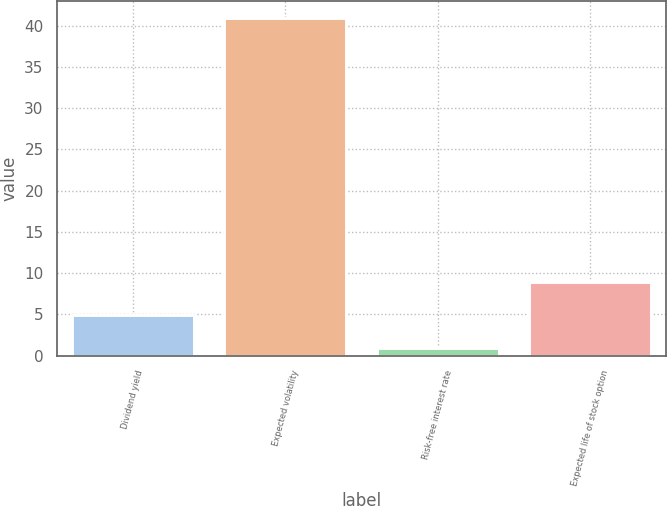Convert chart to OTSL. <chart><loc_0><loc_0><loc_500><loc_500><bar_chart><fcel>Dividend yield<fcel>Expected volatility<fcel>Risk-free interest rate<fcel>Expected life of stock option<nl><fcel>4.91<fcel>41<fcel>0.9<fcel>8.92<nl></chart> 